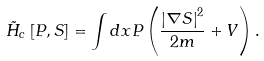Convert formula to latex. <formula><loc_0><loc_0><loc_500><loc_500>\tilde { H } _ { c } \left [ P , S \right ] = \int d x P \left ( \frac { \left | \nabla S \right | ^ { 2 } } { 2 m } + V \right ) .</formula> 